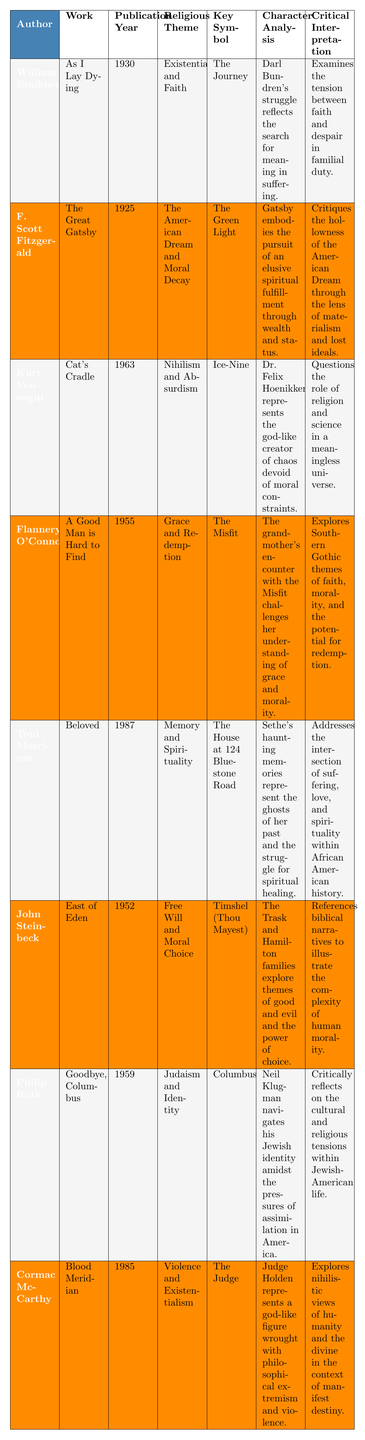What is the religious theme of "As I Lay Dying"? The table states that the religious theme of "As I Lay Dying" by William Faulkner is "Existentialism and Faith."
Answer: Existentialism and Faith Who is the character associated with the symbol "The Green Light"? According to the table, the character associated with the symbol "The Green Light" is Gatsby from "The Great Gatsby."
Answer: Gatsby Which work published in 1987 explores the themes of Memory and Spirituality? The table indicates that "Beloved," published in 1987, explores the themes of Memory and Spirituality.
Answer: Beloved What year was "Cat's Cradle" published? The publication year for "Cat's Cradle" by Kurt Vonnegut, as per the table, is 1963.
Answer: 1963 Which author wrote about "Grace and Redemption" in a work published in 1955? The table shows that Flannery O'Connor wrote about "Grace and Redemption" in "A Good Man is Hard to Find," published in 1955.
Answer: Flannery O'Connor Is "The Judge" a key symbol in any literary work? Yes, "The Judge" is listed as a key symbol in "Blood Meridian" by Cormac McCarthy.
Answer: Yes What common religious theme is explored by both William Faulkner and John Steinbeck? The table does not explicitly state a common theme, but examining both works reveals they both engage with themes of morality—Existentialism and Faith in Faulkner's work and Free Will and Moral Choice in Steinbeck's.
Answer: No common theme What is the character analysis of Sethe in "Beloved"? According to the table, Sethe's haunting memories represent the ghosts of her past and the struggle for spiritual healing.
Answer: Haunting memories and spiritual healing Which character’s encounter challenges their understanding of morality? The grandmother’s encounter with the Misfit in "A Good Man is Hard to Find" challenges her understanding of morality.
Answer: The grandmother How many works listed in the table reflect on the American Dream? The table indicates that two works, "The Great Gatsby" by F. Scott Fitzgerald and the themes present in Philip Roth's "Goodbye, Columbus" discuss the American Dream.
Answer: Two works Which author has a character that represents a god-like creator of chaos? The table shows that Dr. Felix Hoenikker from Kurt Vonnegut's "Cat's Cradle" represents a god-like creator of chaos.
Answer: Kurt Vonnegut What are the key symbols and religious themes in "East of Eden"? In "East of Eden," the key symbol is "Timshel (Thou Mayest)," and the religious theme is "Free Will and Moral Choice."
Answer: Timshel (Thou Mayest); Free Will and Moral Choice Which two authors discussed themes related to identity? According to the table, Philip Roth in "Goodbye, Columbus" discusses themes related to identity, particularly Judaism and identity. Toni Morrison's "Beloved" also connects with identity through spirituality, but is not as explicitly focused.
Answer: Philip Roth and Toni Morrison How does "Blood Meridian" interpret the concept of humanity? The table indicates that "Blood Meridian" explores nihilistic views of humanity and the divine, particularly through the character of Judge Holden.
Answer: Nihilistic views of humanity Are there any works published before 1950 that discuss redemption? Yes, "A Good Man is Hard to Find" by Flannery O'Connor, published in 1955, discusses redemption, but it is essential to check for works before 1950. "As I Lay Dying" also reflects themes of faith and existentialism without explicit redemption.
Answer: Yes, only Flannery O'Connor's work fits this 